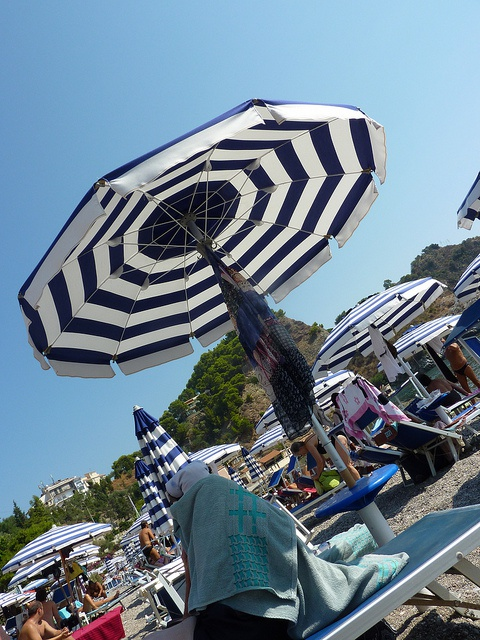Describe the objects in this image and their specific colors. I can see umbrella in darkgray, black, lightgray, and navy tones, people in darkgray, blue, black, darkblue, and gray tones, umbrella in darkgray, lightblue, black, and gray tones, dining table in darkgray, gray, and blue tones, and umbrella in darkgray, lightgray, black, and gray tones in this image. 